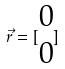<formula> <loc_0><loc_0><loc_500><loc_500>\vec { r } = [ \begin{matrix} 0 \\ 0 \end{matrix} ]</formula> 